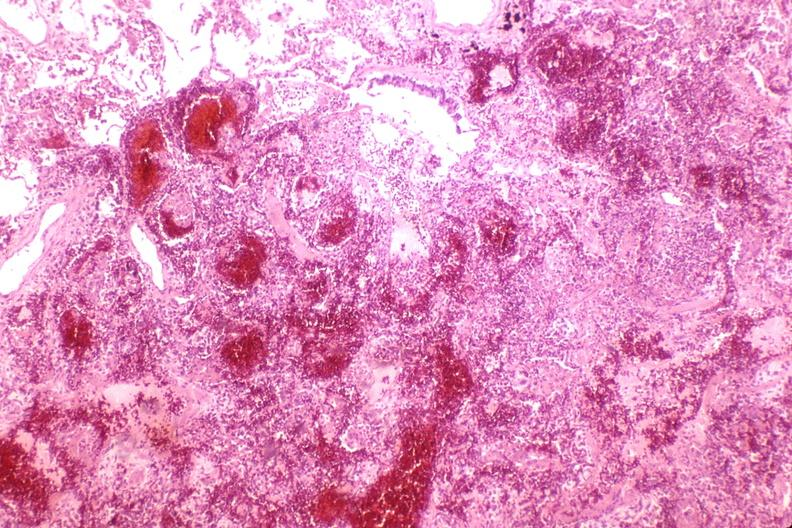what is present?
Answer the question using a single word or phrase. Respiratory 